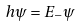<formula> <loc_0><loc_0><loc_500><loc_500>h \psi = E _ { - } \psi</formula> 